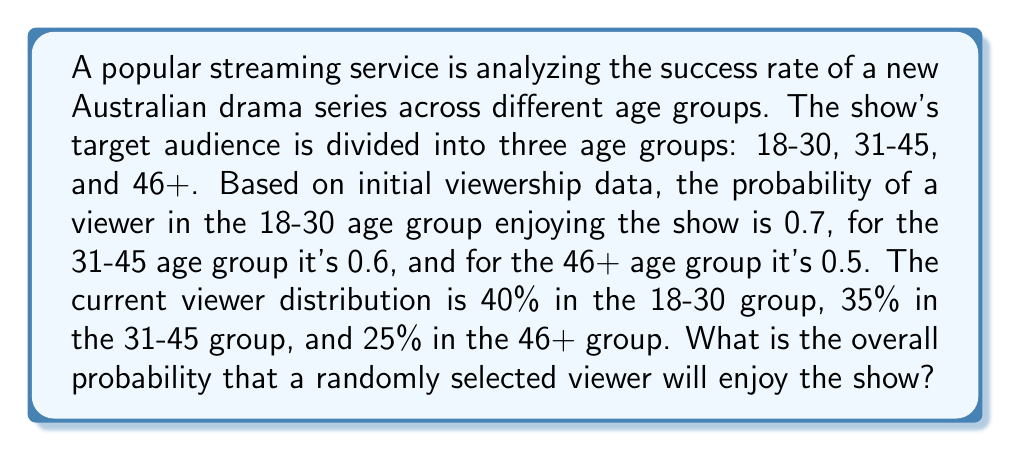Give your solution to this math problem. To solve this problem, we need to use the law of total probability. Let's break it down step by step:

1) Let E be the event that a viewer enjoys the show. We need to calculate P(E).

2) Let A, B, and C represent the events of a viewer being in the 18-30, 31-45, and 46+ age groups respectively.

3) Given:
   P(E|A) = 0.7
   P(E|B) = 0.6
   P(E|C) = 0.5
   P(A) = 0.4
   P(B) = 0.35
   P(C) = 0.25

4) By the law of total probability:

   $$P(E) = P(E|A)P(A) + P(E|B)P(B) + P(E|C)P(C)$$

5) Substituting the values:

   $$P(E) = (0.7)(0.4) + (0.6)(0.35) + (0.5)(0.25)$$

6) Calculating:

   $$P(E) = 0.28 + 0.21 + 0.125 = 0.615$$

Therefore, the overall probability that a randomly selected viewer will enjoy the show is 0.615 or 61.5%.
Answer: 0.615 or 61.5% 